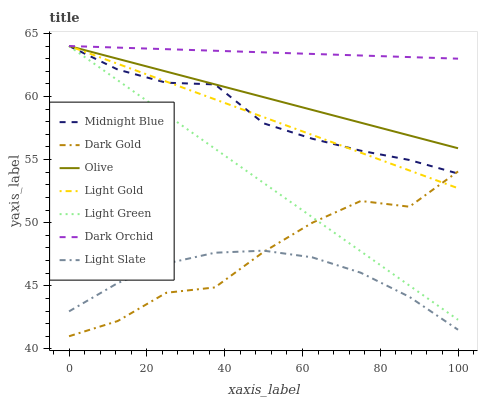Does Light Slate have the minimum area under the curve?
Answer yes or no. Yes. Does Dark Orchid have the maximum area under the curve?
Answer yes or no. Yes. Does Dark Gold have the minimum area under the curve?
Answer yes or no. No. Does Dark Gold have the maximum area under the curve?
Answer yes or no. No. Is Dark Orchid the smoothest?
Answer yes or no. Yes. Is Dark Gold the roughest?
Answer yes or no. Yes. Is Light Slate the smoothest?
Answer yes or no. No. Is Light Slate the roughest?
Answer yes or no. No. Does Dark Gold have the lowest value?
Answer yes or no. Yes. Does Light Slate have the lowest value?
Answer yes or no. No. Does Light Gold have the highest value?
Answer yes or no. Yes. Does Dark Gold have the highest value?
Answer yes or no. No. Is Light Slate less than Light Green?
Answer yes or no. Yes. Is Light Gold greater than Light Slate?
Answer yes or no. Yes. Does Dark Gold intersect Light Slate?
Answer yes or no. Yes. Is Dark Gold less than Light Slate?
Answer yes or no. No. Is Dark Gold greater than Light Slate?
Answer yes or no. No. Does Light Slate intersect Light Green?
Answer yes or no. No. 